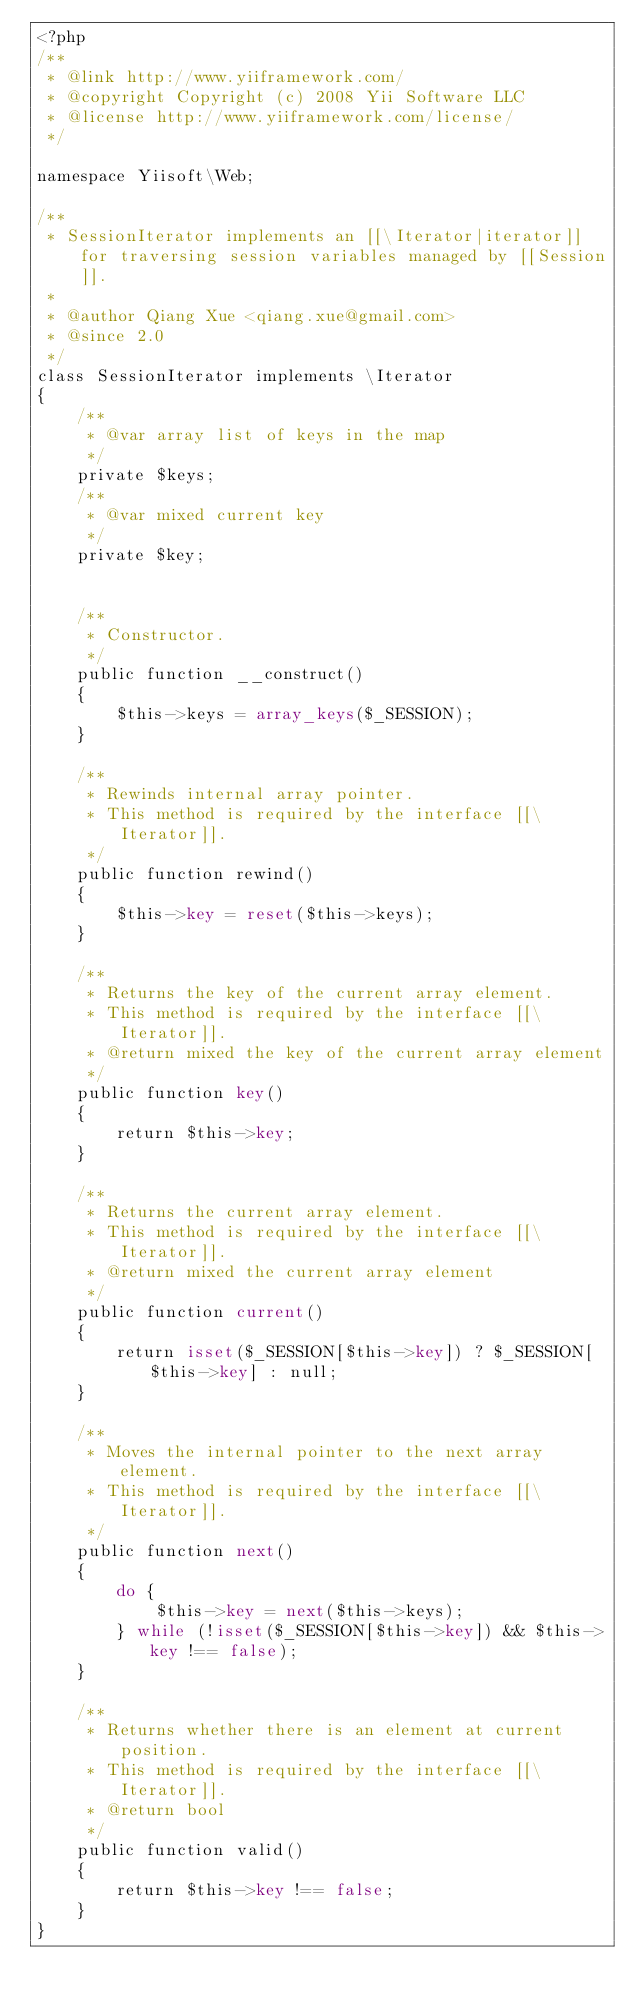Convert code to text. <code><loc_0><loc_0><loc_500><loc_500><_PHP_><?php
/**
 * @link http://www.yiiframework.com/
 * @copyright Copyright (c) 2008 Yii Software LLC
 * @license http://www.yiiframework.com/license/
 */

namespace Yiisoft\Web;

/**
 * SessionIterator implements an [[\Iterator|iterator]] for traversing session variables managed by [[Session]].
 *
 * @author Qiang Xue <qiang.xue@gmail.com>
 * @since 2.0
 */
class SessionIterator implements \Iterator
{
    /**
     * @var array list of keys in the map
     */
    private $keys;
    /**
     * @var mixed current key
     */
    private $key;


    /**
     * Constructor.
     */
    public function __construct()
    {
        $this->keys = array_keys($_SESSION);
    }

    /**
     * Rewinds internal array pointer.
     * This method is required by the interface [[\Iterator]].
     */
    public function rewind()
    {
        $this->key = reset($this->keys);
    }

    /**
     * Returns the key of the current array element.
     * This method is required by the interface [[\Iterator]].
     * @return mixed the key of the current array element
     */
    public function key()
    {
        return $this->key;
    }

    /**
     * Returns the current array element.
     * This method is required by the interface [[\Iterator]].
     * @return mixed the current array element
     */
    public function current()
    {
        return isset($_SESSION[$this->key]) ? $_SESSION[$this->key] : null;
    }

    /**
     * Moves the internal pointer to the next array element.
     * This method is required by the interface [[\Iterator]].
     */
    public function next()
    {
        do {
            $this->key = next($this->keys);
        } while (!isset($_SESSION[$this->key]) && $this->key !== false);
    }

    /**
     * Returns whether there is an element at current position.
     * This method is required by the interface [[\Iterator]].
     * @return bool
     */
    public function valid()
    {
        return $this->key !== false;
    }
}
</code> 